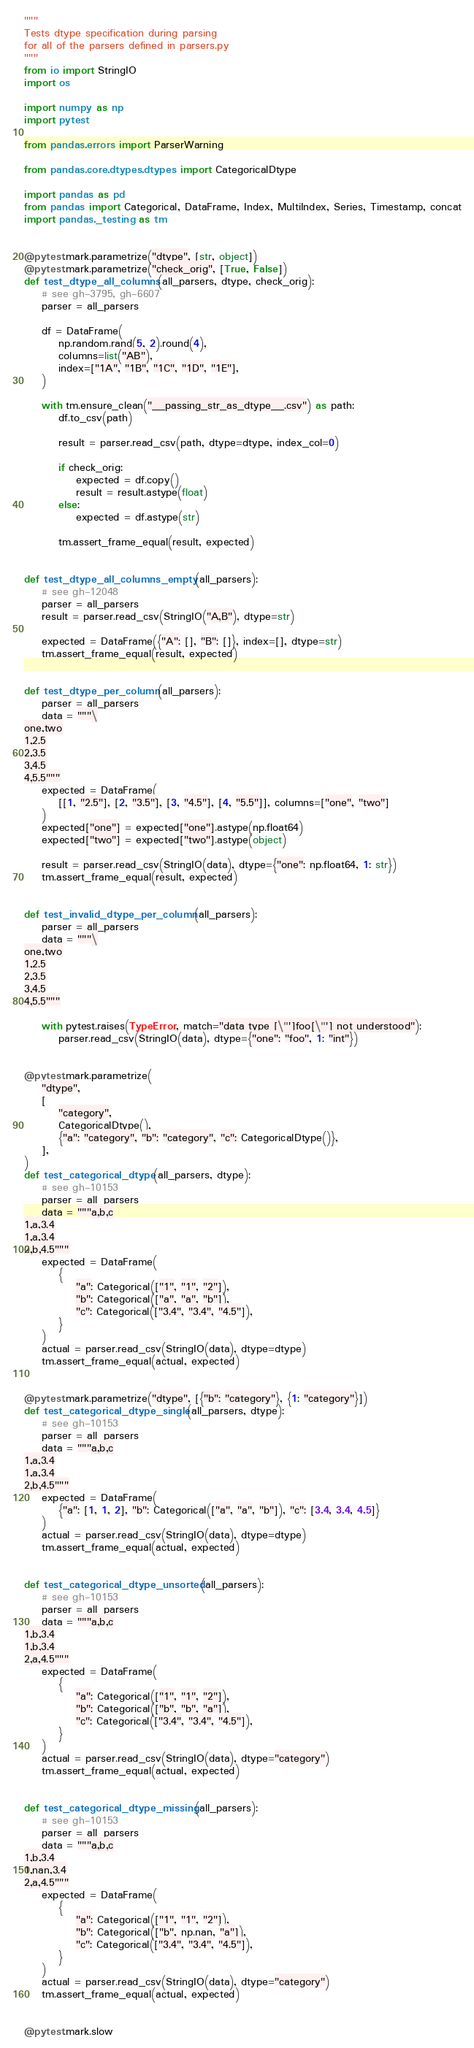<code> <loc_0><loc_0><loc_500><loc_500><_Python_>"""
Tests dtype specification during parsing
for all of the parsers defined in parsers.py
"""
from io import StringIO
import os

import numpy as np
import pytest

from pandas.errors import ParserWarning

from pandas.core.dtypes.dtypes import CategoricalDtype

import pandas as pd
from pandas import Categorical, DataFrame, Index, MultiIndex, Series, Timestamp, concat
import pandas._testing as tm


@pytest.mark.parametrize("dtype", [str, object])
@pytest.mark.parametrize("check_orig", [True, False])
def test_dtype_all_columns(all_parsers, dtype, check_orig):
    # see gh-3795, gh-6607
    parser = all_parsers

    df = DataFrame(
        np.random.rand(5, 2).round(4),
        columns=list("AB"),
        index=["1A", "1B", "1C", "1D", "1E"],
    )

    with tm.ensure_clean("__passing_str_as_dtype__.csv") as path:
        df.to_csv(path)

        result = parser.read_csv(path, dtype=dtype, index_col=0)

        if check_orig:
            expected = df.copy()
            result = result.astype(float)
        else:
            expected = df.astype(str)

        tm.assert_frame_equal(result, expected)


def test_dtype_all_columns_empty(all_parsers):
    # see gh-12048
    parser = all_parsers
    result = parser.read_csv(StringIO("A,B"), dtype=str)

    expected = DataFrame({"A": [], "B": []}, index=[], dtype=str)
    tm.assert_frame_equal(result, expected)


def test_dtype_per_column(all_parsers):
    parser = all_parsers
    data = """\
one,two
1,2.5
2,3.5
3,4.5
4,5.5"""
    expected = DataFrame(
        [[1, "2.5"], [2, "3.5"], [3, "4.5"], [4, "5.5"]], columns=["one", "two"]
    )
    expected["one"] = expected["one"].astype(np.float64)
    expected["two"] = expected["two"].astype(object)

    result = parser.read_csv(StringIO(data), dtype={"one": np.float64, 1: str})
    tm.assert_frame_equal(result, expected)


def test_invalid_dtype_per_column(all_parsers):
    parser = all_parsers
    data = """\
one,two
1,2.5
2,3.5
3,4.5
4,5.5"""

    with pytest.raises(TypeError, match="data type [\"']foo[\"'] not understood"):
        parser.read_csv(StringIO(data), dtype={"one": "foo", 1: "int"})


@pytest.mark.parametrize(
    "dtype",
    [
        "category",
        CategoricalDtype(),
        {"a": "category", "b": "category", "c": CategoricalDtype()},
    ],
)
def test_categorical_dtype(all_parsers, dtype):
    # see gh-10153
    parser = all_parsers
    data = """a,b,c
1,a,3.4
1,a,3.4
2,b,4.5"""
    expected = DataFrame(
        {
            "a": Categorical(["1", "1", "2"]),
            "b": Categorical(["a", "a", "b"]),
            "c": Categorical(["3.4", "3.4", "4.5"]),
        }
    )
    actual = parser.read_csv(StringIO(data), dtype=dtype)
    tm.assert_frame_equal(actual, expected)


@pytest.mark.parametrize("dtype", [{"b": "category"}, {1: "category"}])
def test_categorical_dtype_single(all_parsers, dtype):
    # see gh-10153
    parser = all_parsers
    data = """a,b,c
1,a,3.4
1,a,3.4
2,b,4.5"""
    expected = DataFrame(
        {"a": [1, 1, 2], "b": Categorical(["a", "a", "b"]), "c": [3.4, 3.4, 4.5]}
    )
    actual = parser.read_csv(StringIO(data), dtype=dtype)
    tm.assert_frame_equal(actual, expected)


def test_categorical_dtype_unsorted(all_parsers):
    # see gh-10153
    parser = all_parsers
    data = """a,b,c
1,b,3.4
1,b,3.4
2,a,4.5"""
    expected = DataFrame(
        {
            "a": Categorical(["1", "1", "2"]),
            "b": Categorical(["b", "b", "a"]),
            "c": Categorical(["3.4", "3.4", "4.5"]),
        }
    )
    actual = parser.read_csv(StringIO(data), dtype="category")
    tm.assert_frame_equal(actual, expected)


def test_categorical_dtype_missing(all_parsers):
    # see gh-10153
    parser = all_parsers
    data = """a,b,c
1,b,3.4
1,nan,3.4
2,a,4.5"""
    expected = DataFrame(
        {
            "a": Categorical(["1", "1", "2"]),
            "b": Categorical(["b", np.nan, "a"]),
            "c": Categorical(["3.4", "3.4", "4.5"]),
        }
    )
    actual = parser.read_csv(StringIO(data), dtype="category")
    tm.assert_frame_equal(actual, expected)


@pytest.mark.slow</code> 